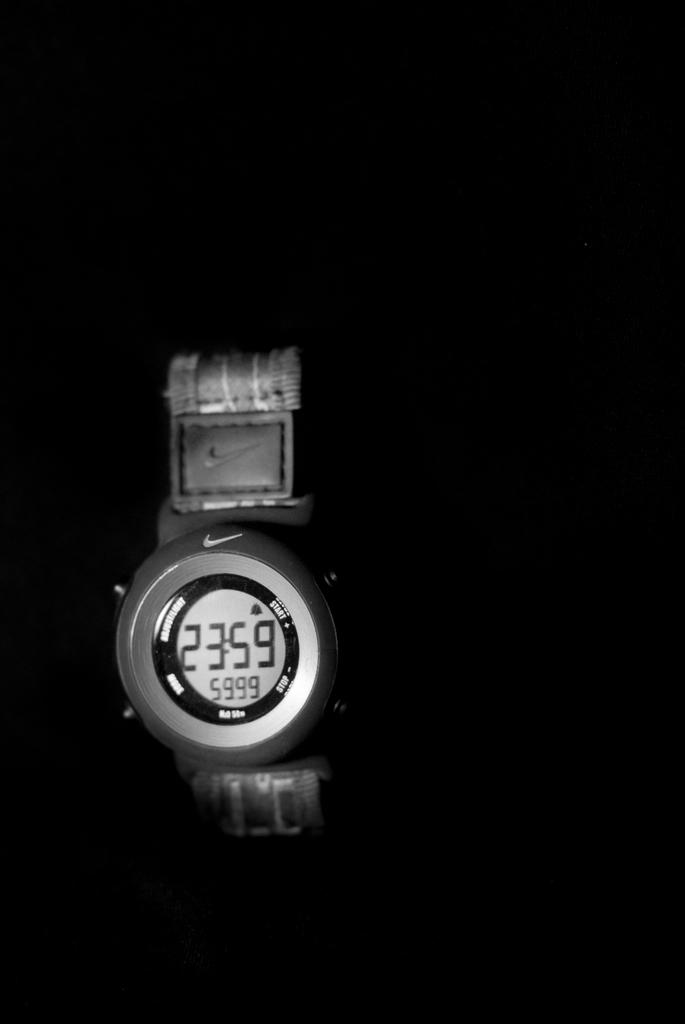Provide a one-sentence caption for the provided image. A silver watch with a nike symbol on it has the time 23:59 on it. 